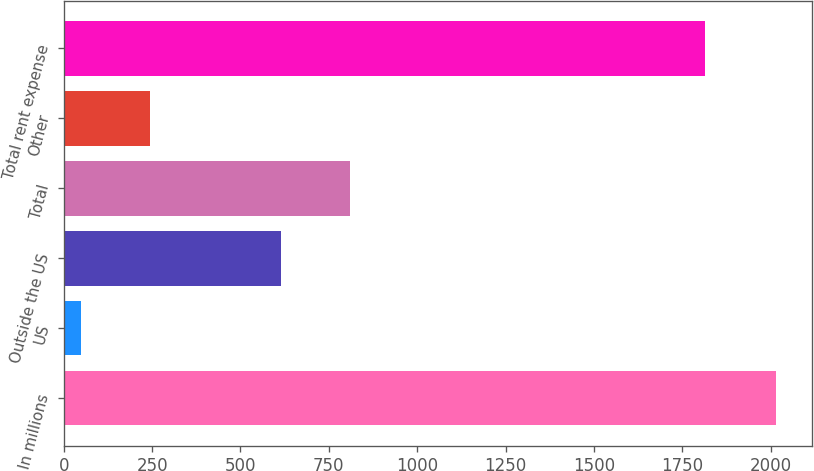Convert chart. <chart><loc_0><loc_0><loc_500><loc_500><bar_chart><fcel>In millions<fcel>US<fcel>Outside the US<fcel>Total<fcel>Other<fcel>Total rent expense<nl><fcel>2016<fcel>48.6<fcel>613.3<fcel>810.04<fcel>245.34<fcel>1814.2<nl></chart> 